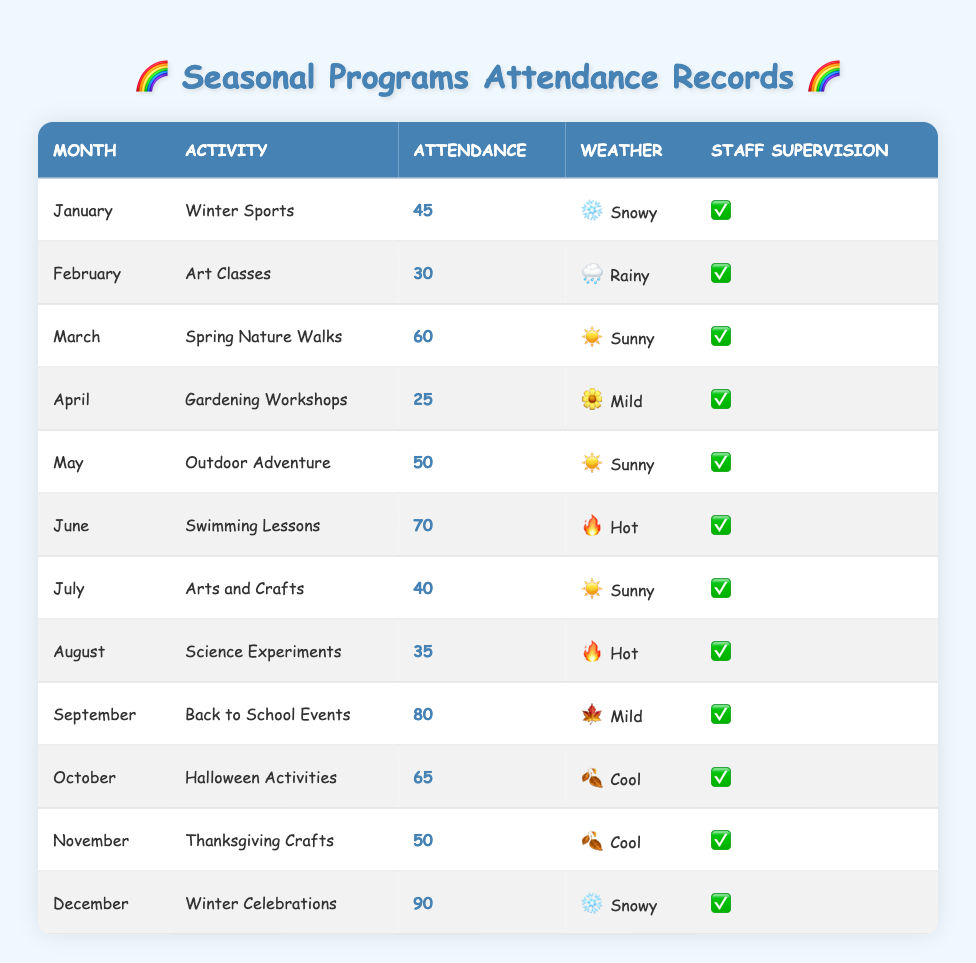What was the total attendance for Swimming Lessons in June? The table shows that the attendance for Swimming Lessons in June is 70.
Answer: 70 Which month had the highest attendance and what was the activity? December had the highest attendance of 90 for the Winter Celebrations activity.
Answer: December, Winter Celebrations Is there staff supervision for the November Thanksgiving Crafts? The table indicates that there is staff supervision indicated by “Yes” for the November Thanksgiving Crafts.
Answer: Yes What is the total attendance for all activities in the summer months (June, July, August)? Adding the attendance numbers for June (70), July (40), and August (35) gives us a total of 70 + 40 + 35 = 145 for summer months.
Answer: 145 How many activities had snowy weather conditions and what were their names? The table lists two activities with snowy weather: Winter Sports in January and Winter Celebrations in December.
Answer: 2 activities: Winter Sports, Winter Celebrations What is the average attendance for activities from April to October? The attendances for April (25), May (50), June (70), July (40), August (35), September (80), October (65) sum to 25 + 50 + 70 + 40 + 35 + 80 + 65 = 365. There are 7 months, so the average is 365 / 7 ≈ 52.14.
Answer: Approximately 52.14 Did any activities have an attendance of more than 80? The table shows that only the September Back to School Events (80) and December Winter Celebrations (90) exceeded an attendance of 80.
Answer: Yes Which activities had a total attendance less than 40? The only activity with an attendance less than 40 is Gardening Workshops in April (25) and Science Experiments in August (35).
Answer: 2 activities: Gardening Workshops, Science Experiments How many activities took place in months with hot weather? According to the table, there are two activities with hot weather: Swimming Lessons in June and Science Experiments in August.
Answer: 2 activities 